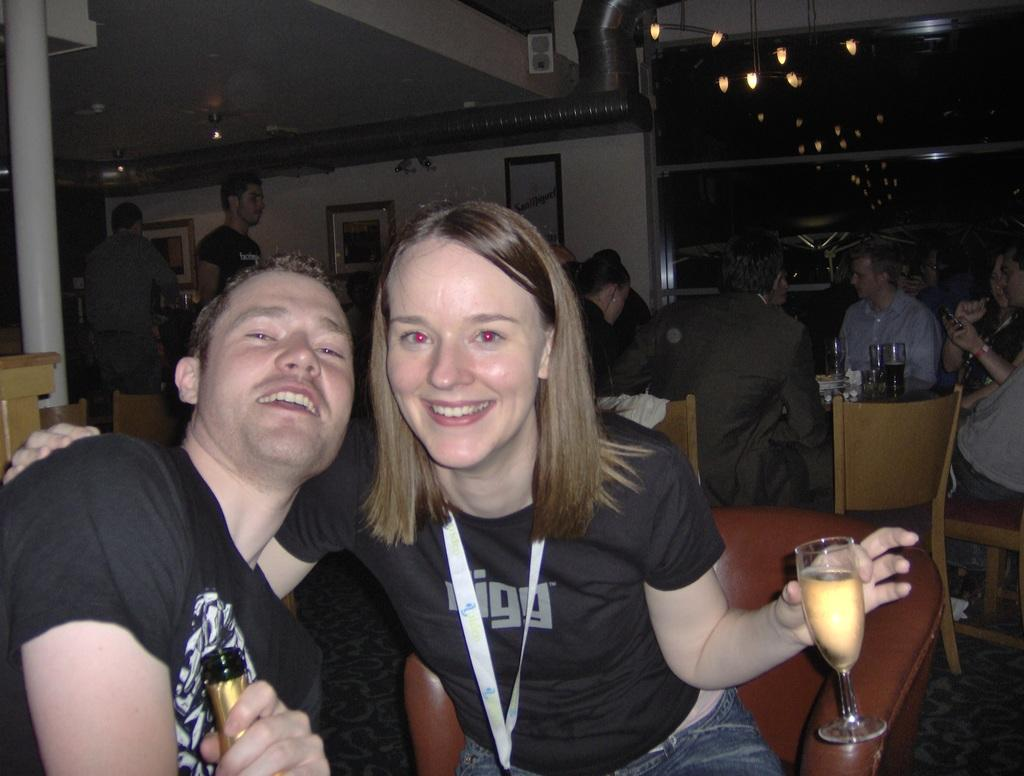<image>
Present a compact description of the photo's key features. Two people posing for a photo while the girl wears a shirt that says rigg. 